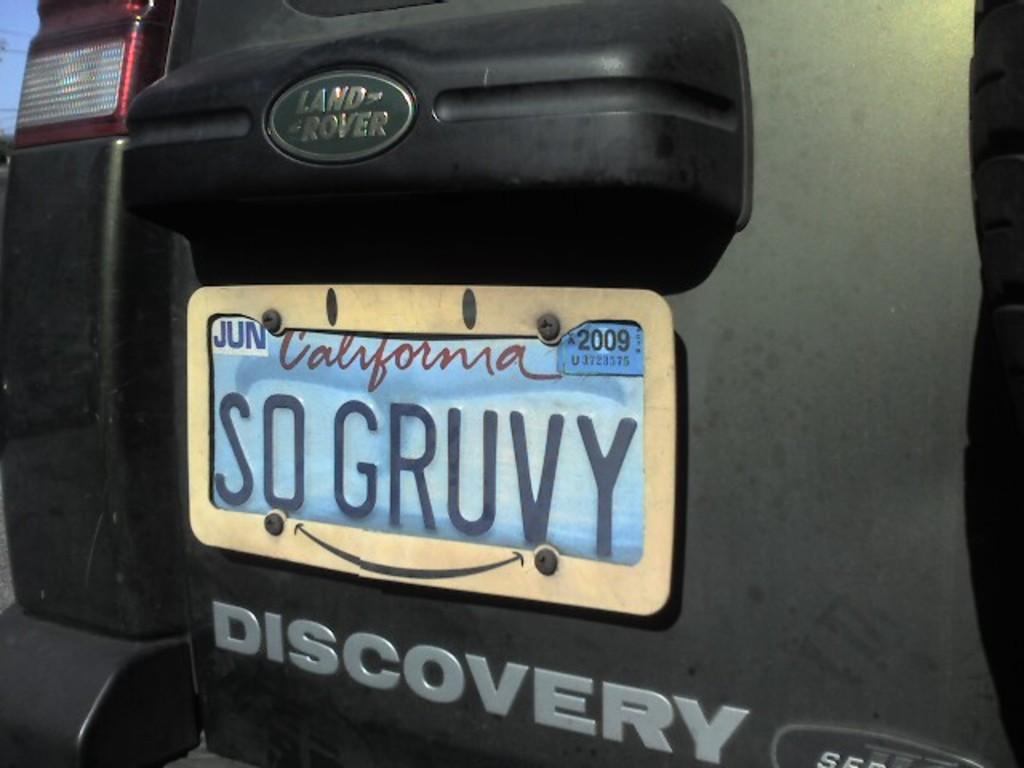<image>
Summarize the visual content of the image. A person who drives a Land Rover thinks they are so gruvy. 